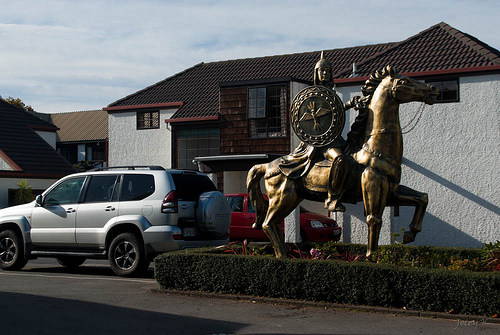<image>
Can you confirm if the statue is behind the car? Yes. From this viewpoint, the statue is positioned behind the car, with the car partially or fully occluding the statue. 